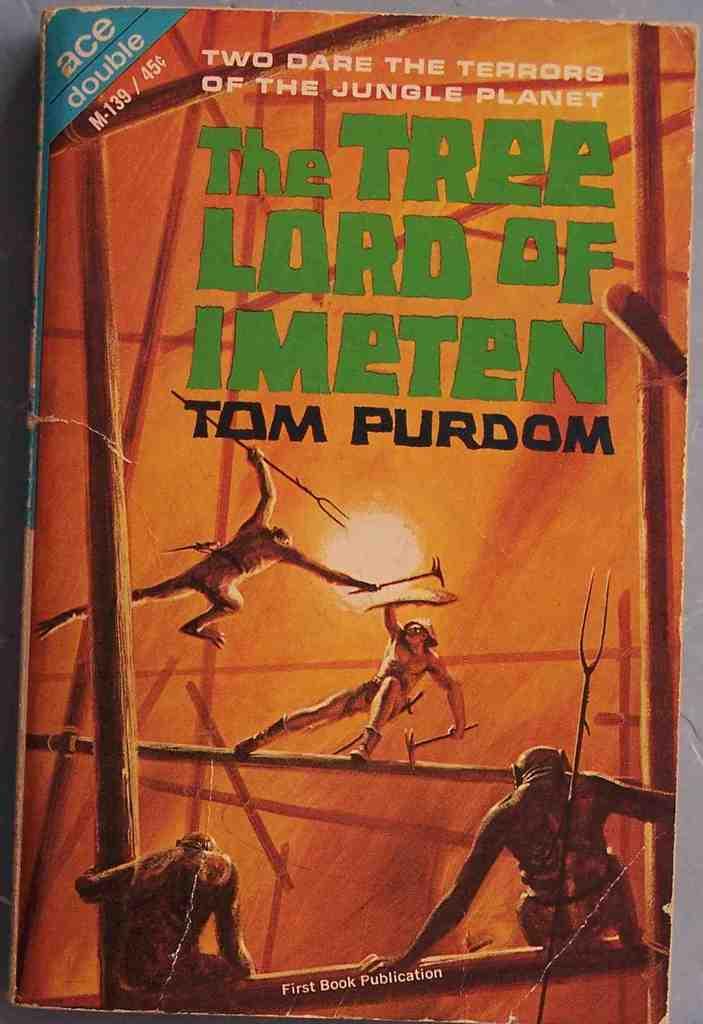Where does this story take place?
Make the answer very short. The jungle planet. 